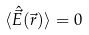Convert formula to latex. <formula><loc_0><loc_0><loc_500><loc_500>\langle \hat { \vec { E } } ( \vec { r } ) \rangle = 0</formula> 